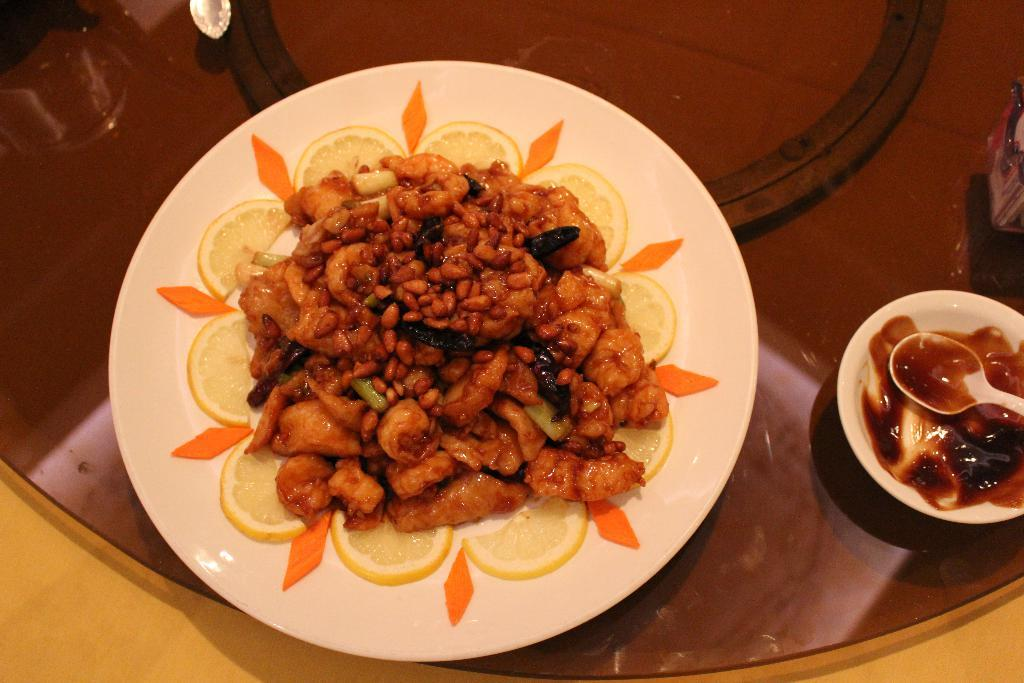What is on the plate can be seen in the image? There is food on a plate in the image. What is in the bowl that is visible in the image? There is a bowl with a spoon in the image. Where are the plate and bowl located in the image? The plate and bowl are kept on a table in the image. How many rings are visible on the plate in the image? There are no rings visible on the plate in the image; it contains food. 